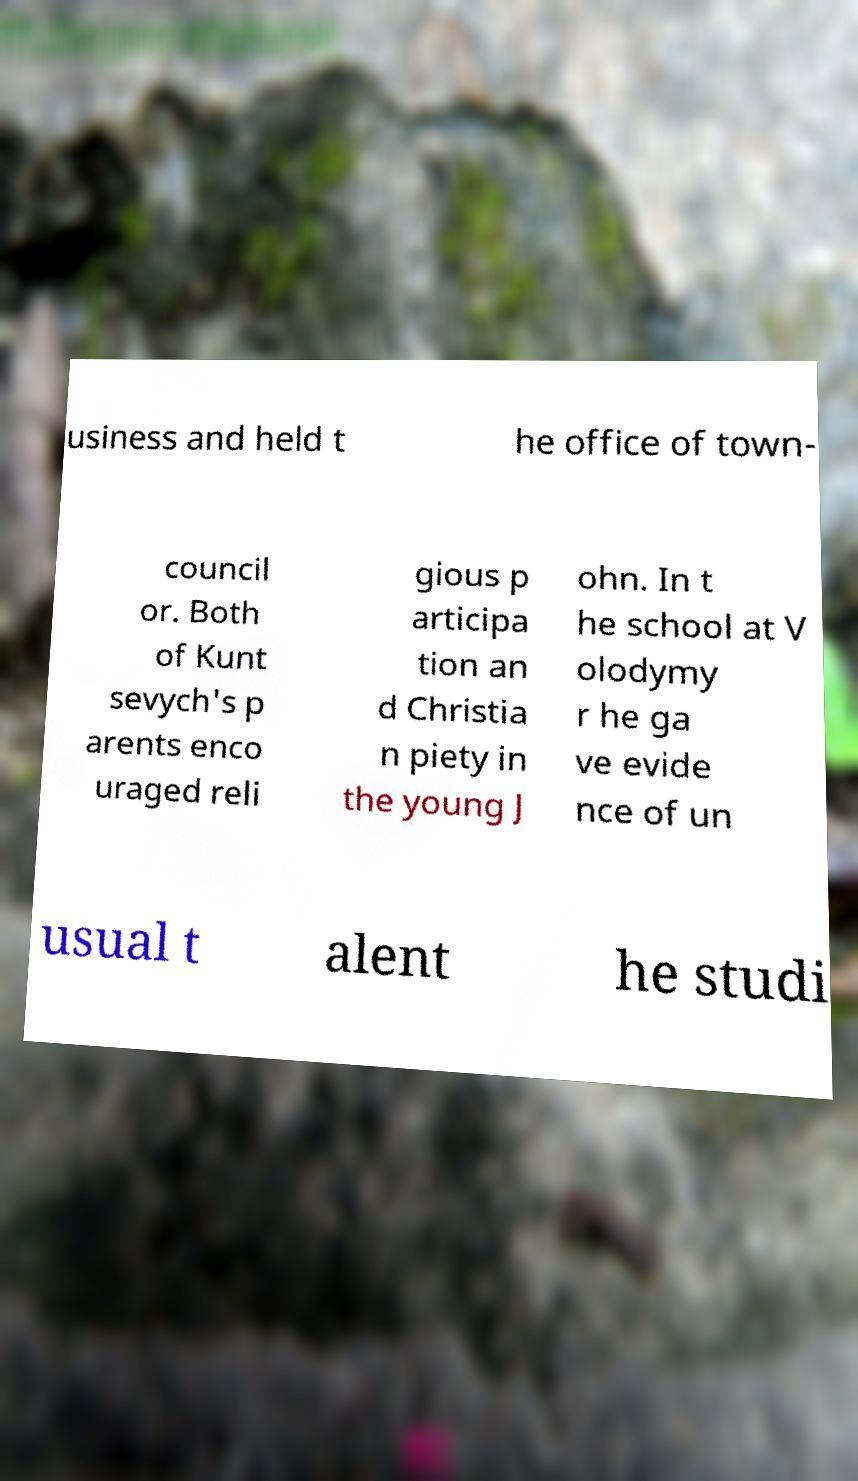Could you assist in decoding the text presented in this image and type it out clearly? usiness and held t he office of town- council or. Both of Kunt sevych's p arents enco uraged reli gious p articipa tion an d Christia n piety in the young J ohn. In t he school at V olodymy r he ga ve evide nce of un usual t alent he studi 